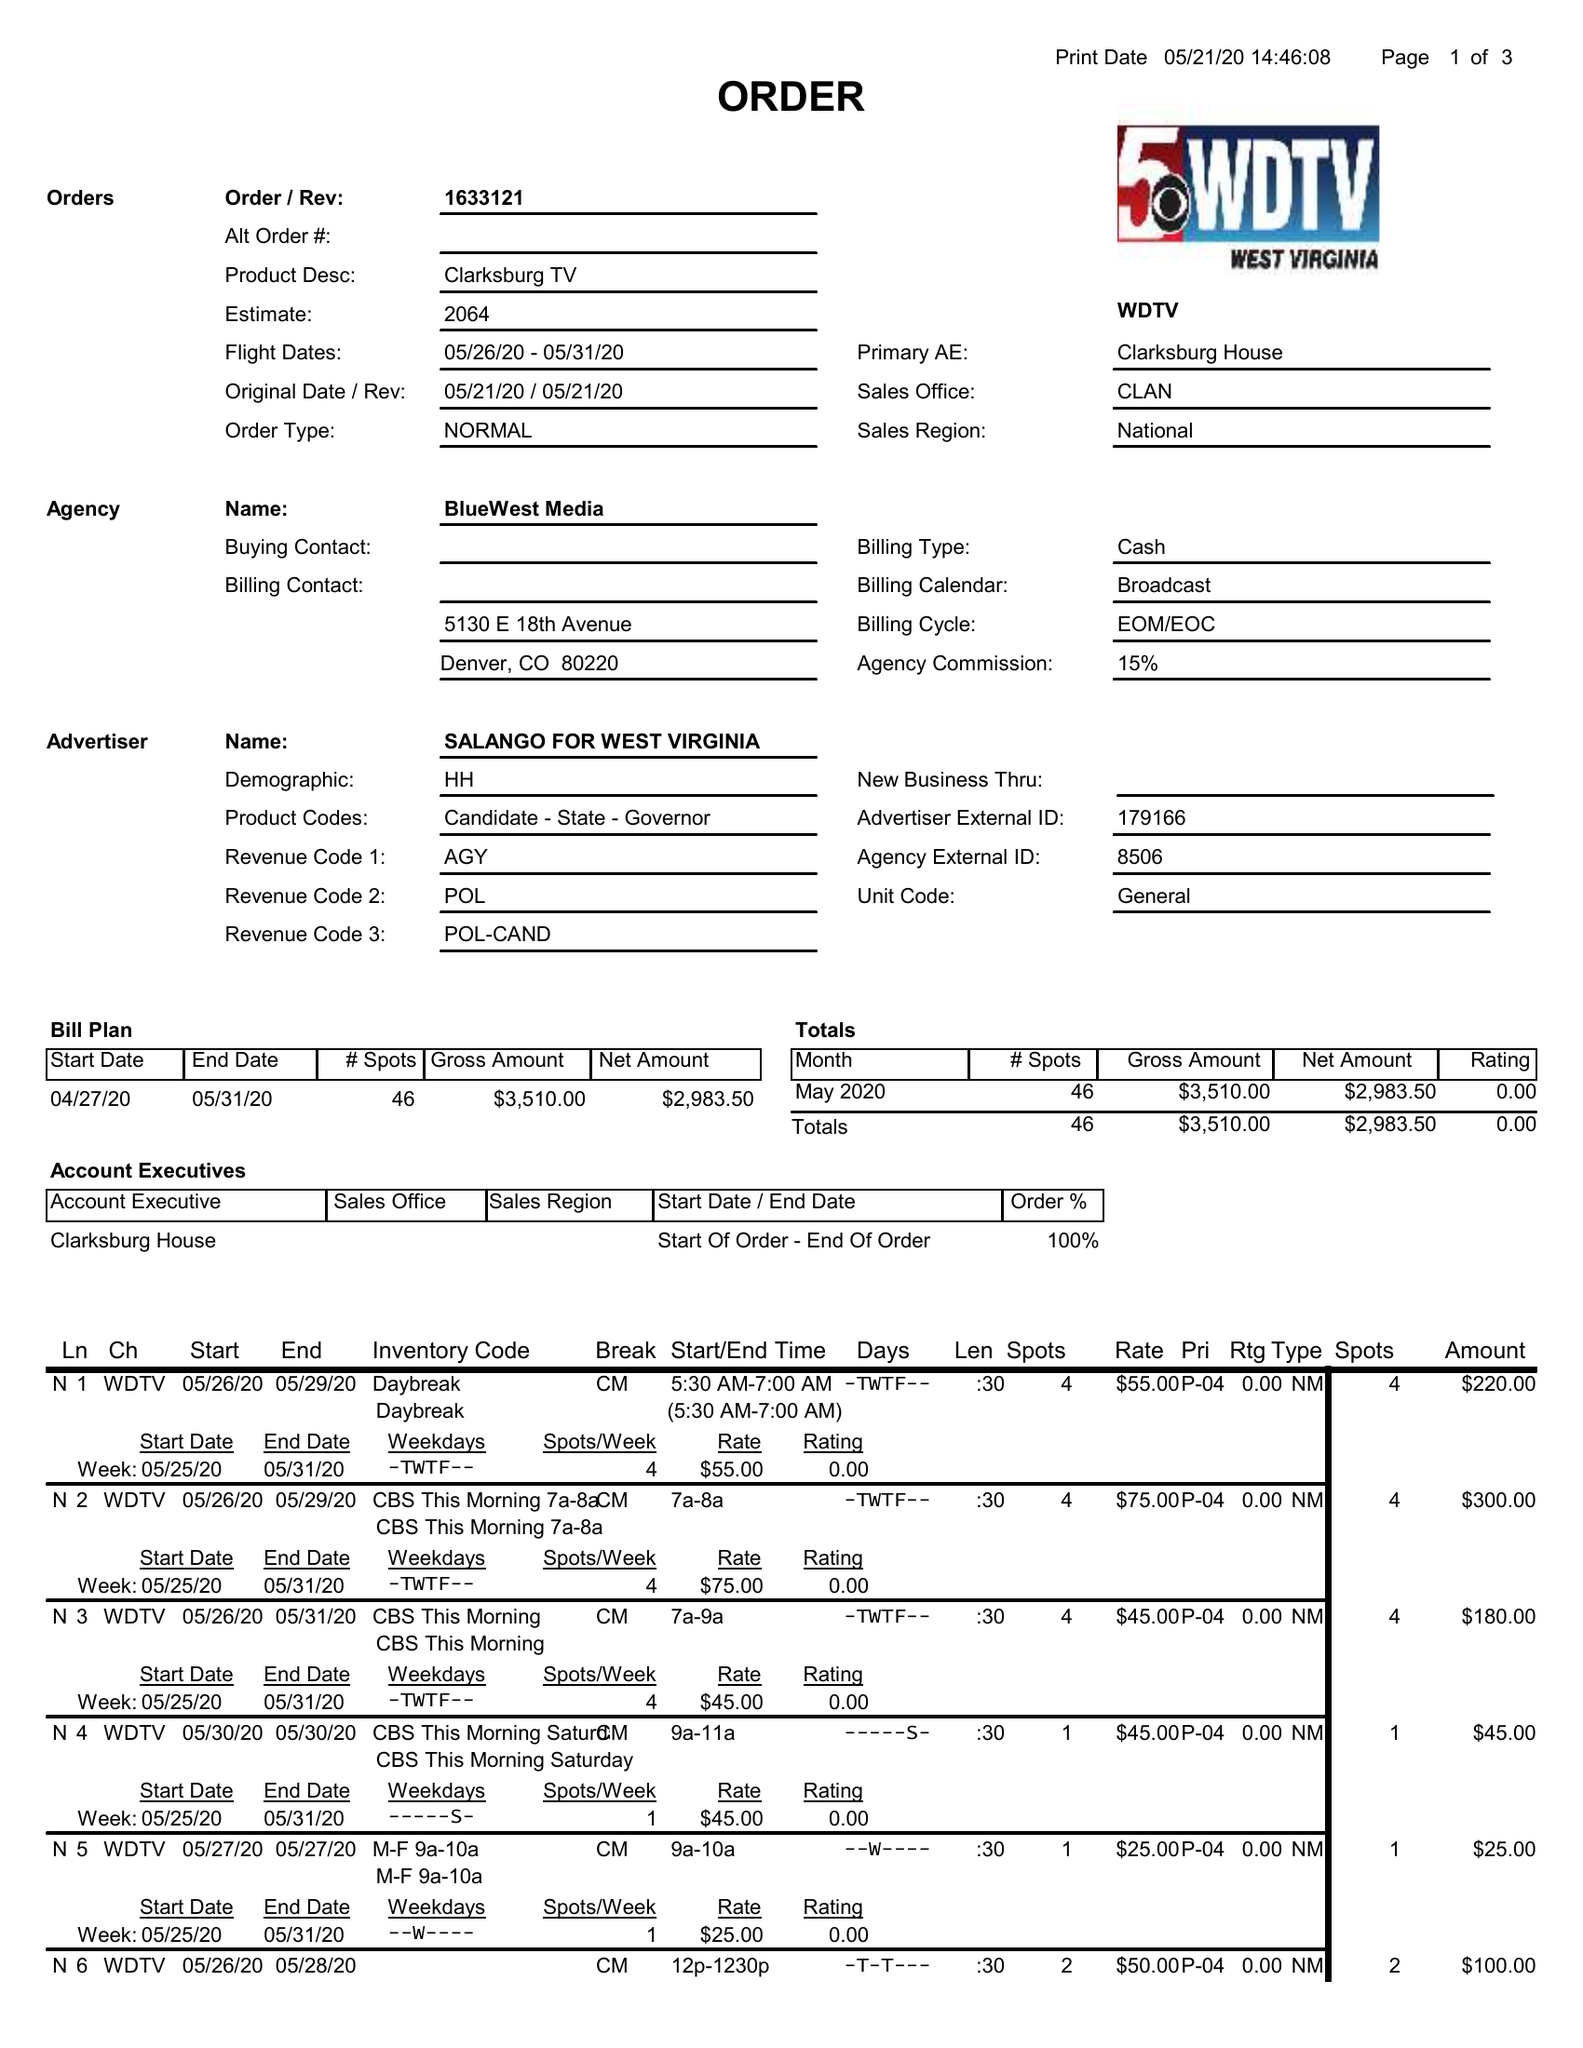What is the value for the contract_num?
Answer the question using a single word or phrase. 1633121 